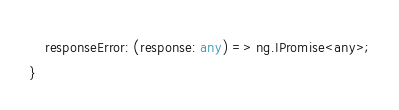Convert code to text. <code><loc_0><loc_0><loc_500><loc_500><_TypeScript_>    responseError: (response: any) => ng.IPromise<any>;
}
</code> 